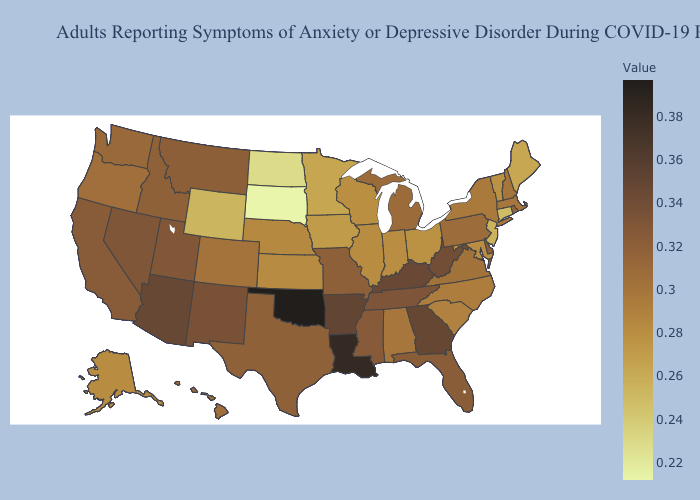Which states have the lowest value in the Northeast?
Write a very short answer. Connecticut. Among the states that border Utah , which have the highest value?
Concise answer only. Arizona. Among the states that border Rhode Island , which have the lowest value?
Be succinct. Connecticut. Which states have the lowest value in the South?
Be succinct. Maryland. Among the states that border California , which have the lowest value?
Short answer required. Oregon. Does Wisconsin have a lower value than Connecticut?
Short answer required. No. Does Arkansas have a lower value than Rhode Island?
Short answer required. No. 